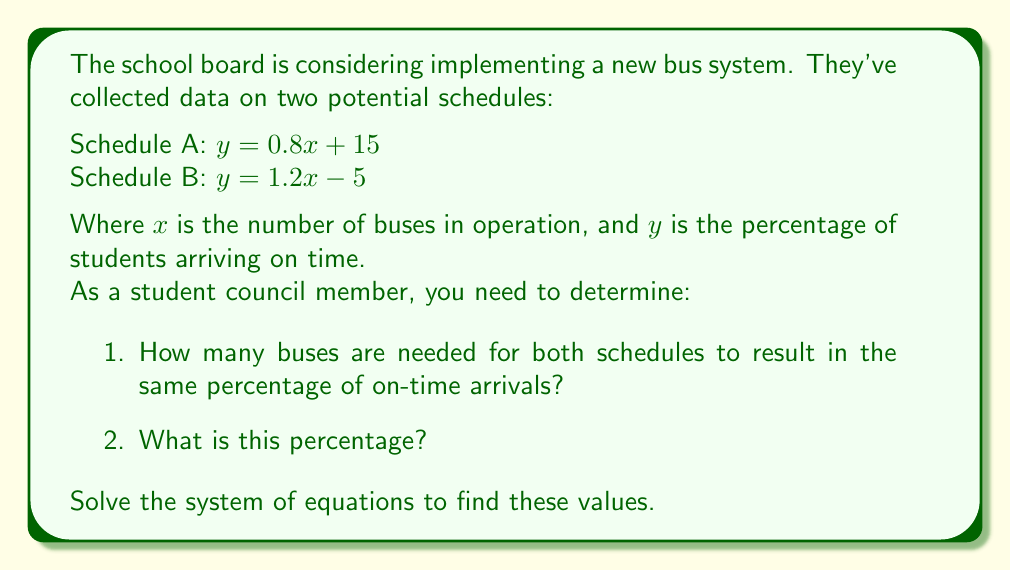Show me your answer to this math problem. Let's approach this step-by-step:

1) We have two equations:
   Schedule A: $y = 0.8x + 15$
   Schedule B: $y = 1.2x - 5$

2) To find where these schedules result in the same percentage of on-time arrivals, we set the equations equal to each other:

   $0.8x + 15 = 1.2x - 5$

3) Now, let's solve for $x$:
   $0.8x + 15 = 1.2x - 5$
   $15 + 5 = 1.2x - 0.8x$
   $20 = 0.4x$
   $x = 20 / 0.4 = 50$

4) So, 50 buses are needed for both schedules to result in the same percentage of on-time arrivals.

5) To find this percentage, we can plug $x = 50$ into either equation. Let's use Schedule A:

   $y = 0.8(50) + 15$
   $y = 40 + 15 = 55$

Therefore, when 50 buses are in operation, 55% of students will arrive on time for both schedules.
Answer: 50 buses; 55% on-time arrivals 